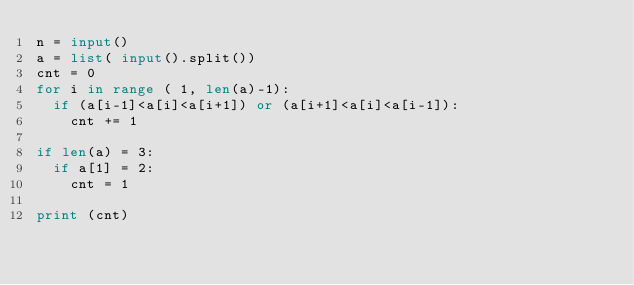Convert code to text. <code><loc_0><loc_0><loc_500><loc_500><_Python_>n = input()
a = list( input().split())
cnt = 0
for i in range ( 1, len(a)-1):
  if (a[i-1]<a[i]<a[i+1]) or (a[i+1]<a[i]<a[i-1]):
    cnt += 1
    
if len(a) = 3:
  if a[1] = 2:
    cnt = 1
    
print (cnt)    </code> 